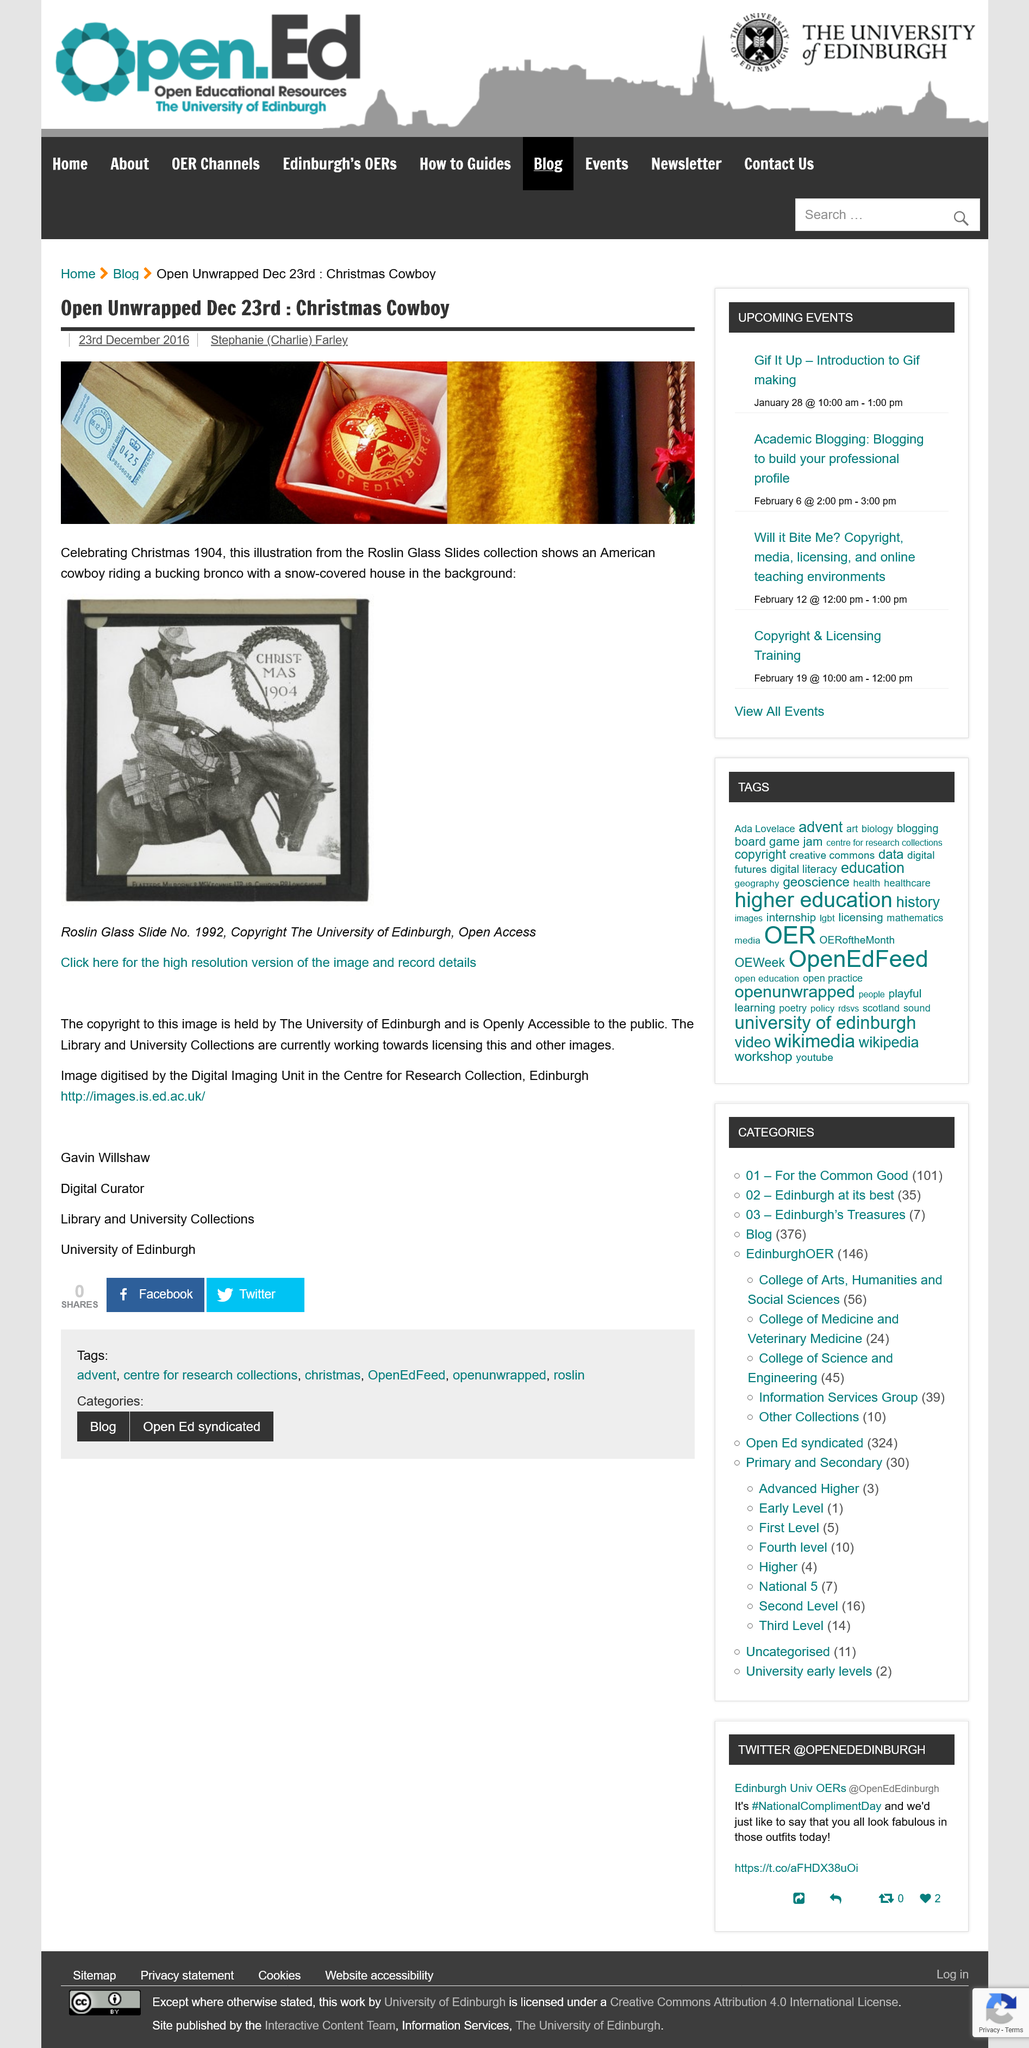Mention a couple of crucial points in this snapshot. The depiction in the illustration represents the year 1904. The university of Edinburgh holds the copyright to the image. The digital curator at the University of Edinburgh is Gavin Willshaw. 